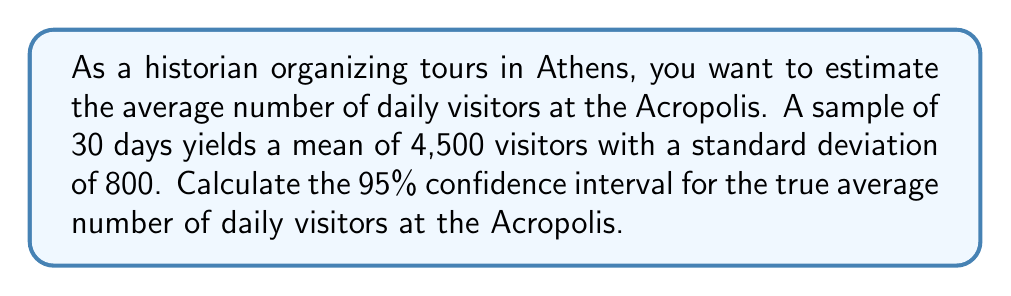Provide a solution to this math problem. To calculate the confidence interval, we'll use the formula:

$$ \text{CI} = \bar{x} \pm t_{\alpha/2} \cdot \frac{s}{\sqrt{n}} $$

Where:
- $\bar{x}$ is the sample mean (4,500)
- $s$ is the sample standard deviation (800)
- $n$ is the sample size (30)
- $t_{\alpha/2}$ is the t-value for a 95% confidence interval with 29 degrees of freedom

Steps:
1) Find $t_{\alpha/2}$: For a 95% CI with 29 df, $t_{\alpha/2} = 2.045$

2) Calculate the margin of error:
   $$ \text{ME} = t_{\alpha/2} \cdot \frac{s}{\sqrt{n}} = 2.045 \cdot \frac{800}{\sqrt{30}} = 298.95 $$

3) Calculate the lower and upper bounds of the CI:
   Lower bound: $4500 - 298.95 = 4201.05$
   Upper bound: $4500 + 298.95 = 4798.95$

4) Round to whole numbers, as we're dealing with visitors:
   CI: (4201, 4799)
Answer: (4201, 4799) visitors per day 